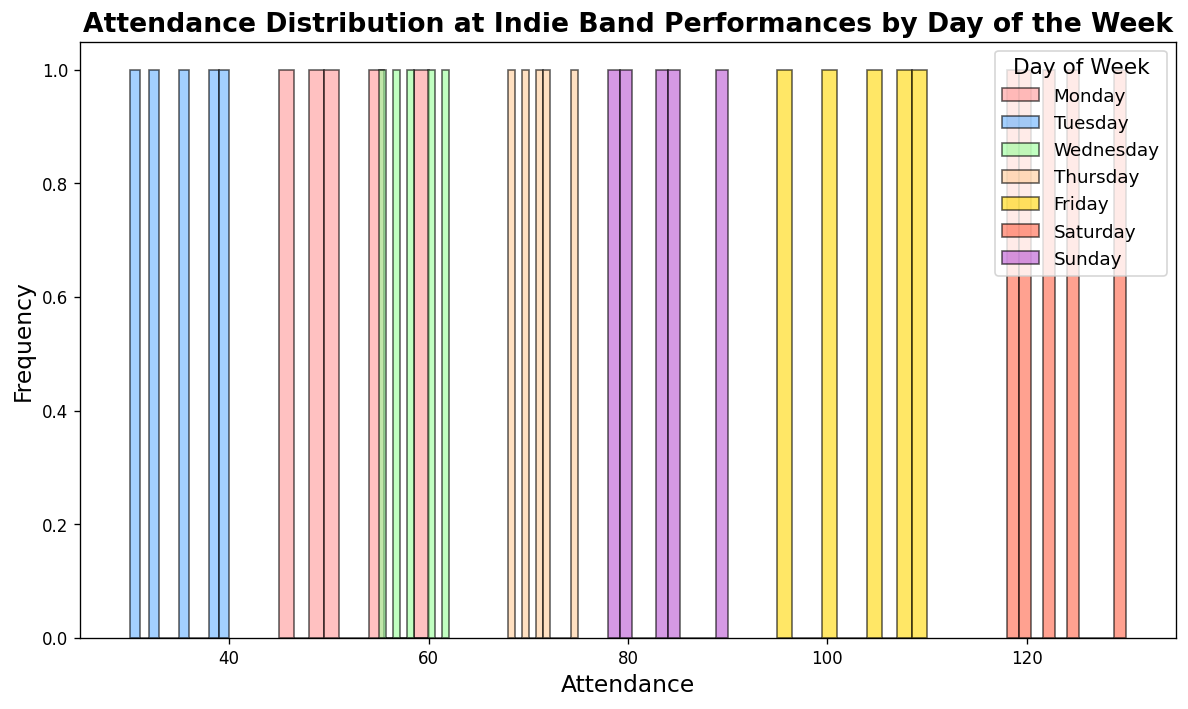Which day has the highest attendance range? First, observe the distribution ranges for each day by looking at the span of the bars (the difference between the highest and lowest values in the attendance). Monday's range is 45 to 60, Tuesday's is 30 to 40, Wednesday's is 55 to 62, Thursday's is 68 to 75, Friday's is 95 to 110, Saturday's is 118 to 130, and Sunday's is 78 to 90. Saturday has the highest attendance range of 118 to 130, which is a span of 12.
Answer: Saturday Which day has the smallest attendance range? Again, observe the distribution ranges for each day based on the span of the bars. The smallest range belongs to Tuesday with a span of 30 to 40, which is a range of 10.
Answer: Tuesday Compare the highest attendance on Saturday and Friday. Which day has higher attendance? Observe the highest bars for Saturday and Friday. Saturday's highest attendance reaches 130, and Friday's highest attendance reaches 110. Therefore, Saturday has higher attendance.
Answer: Saturday On which day is the attendance most consistent? Check the tightness of the distribution of bars for each day. The tighter the cluster, the more consistent the attendance. Tuesday's attendance seems most consistent with a narrow span from 30 to 40.
Answer: Tuesday What's the average attendance on Sunday? Look at the data points for Sunday: 80, 85, 78, 90, 83. Sum them up (80 + 85 + 78 + 90 + 83 = 416) and divide by the number of data points (5). The average attendance is 416/5 = 83.2.
Answer: 83.2 Which day shows the least variability in attendance? Observe the spread of attendance values for each day. The tightest cluster, hence the least variability, appears on Tuesday with a range of 30 to 40.
Answer: Tuesday Which day has a peak attendance around 70? Find the day with bars centered around the value of 70. Thursday's attendance peaks between 68 and 75, which is centered around 70.
Answer: Thursday Which color represents Thursday on the histogram? Check the legend of the histogram to find the color associated with Thursday. The legend shows that Thursday is represented by a light brown color.
Answer: Light brown What's the total number of attendees across all days in the dataset? Sum up the attendance values for each day provided in the data. The total sum is 2823.
Answer: 2823 